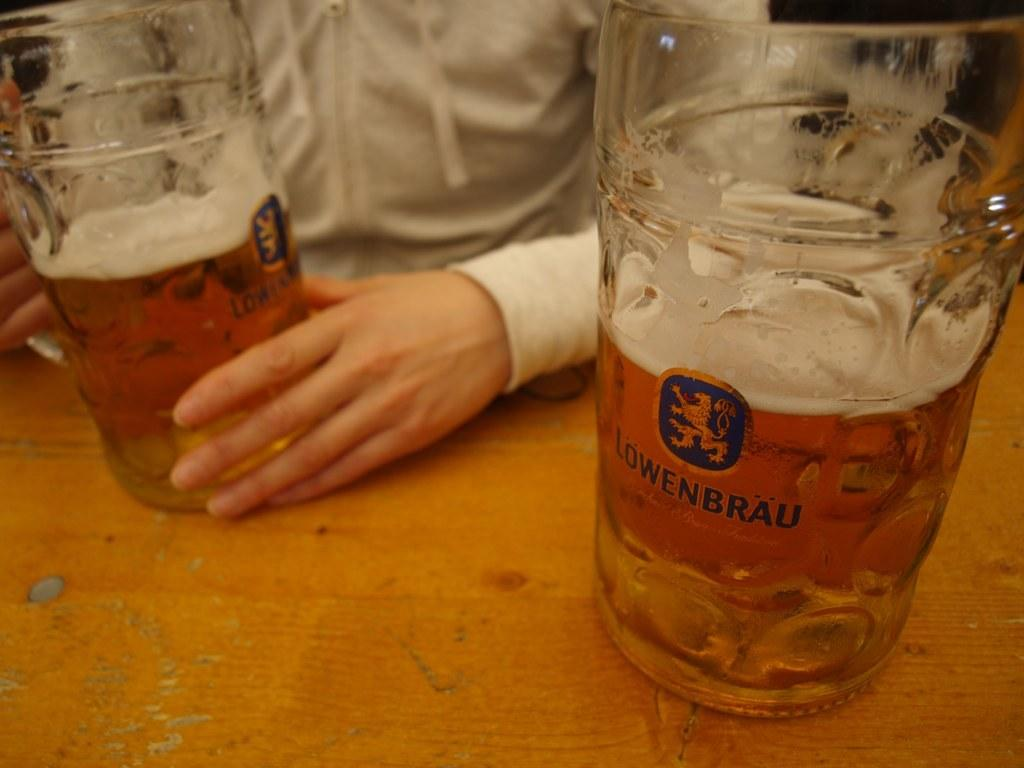<image>
Render a clear and concise summary of the photo. A large beer stein has Lowenbrau on the front in blue letters. 